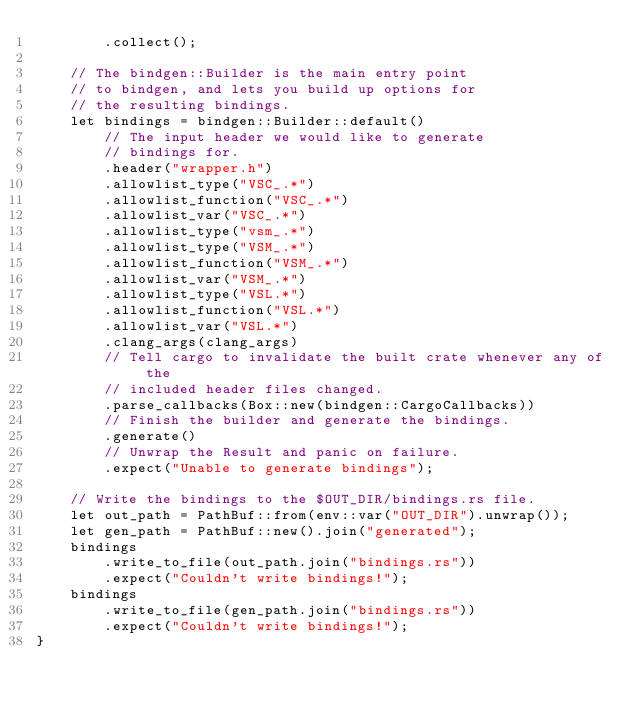<code> <loc_0><loc_0><loc_500><loc_500><_Rust_>        .collect();

    // The bindgen::Builder is the main entry point
    // to bindgen, and lets you build up options for
    // the resulting bindings.
    let bindings = bindgen::Builder::default()
        // The input header we would like to generate
        // bindings for.
        .header("wrapper.h")
        .allowlist_type("VSC_.*")
        .allowlist_function("VSC_.*")
        .allowlist_var("VSC_.*")
        .allowlist_type("vsm_.*")
        .allowlist_type("VSM_.*")
        .allowlist_function("VSM_.*")
        .allowlist_var("VSM_.*")
        .allowlist_type("VSL.*")
        .allowlist_function("VSL.*")
        .allowlist_var("VSL.*")
        .clang_args(clang_args)
        // Tell cargo to invalidate the built crate whenever any of the
        // included header files changed.
        .parse_callbacks(Box::new(bindgen::CargoCallbacks))
        // Finish the builder and generate the bindings.
        .generate()
        // Unwrap the Result and panic on failure.
        .expect("Unable to generate bindings");

    // Write the bindings to the $OUT_DIR/bindings.rs file.
    let out_path = PathBuf::from(env::var("OUT_DIR").unwrap());
    let gen_path = PathBuf::new().join("generated");
    bindings
        .write_to_file(out_path.join("bindings.rs"))
        .expect("Couldn't write bindings!");
    bindings
        .write_to_file(gen_path.join("bindings.rs"))
        .expect("Couldn't write bindings!");
}
</code> 